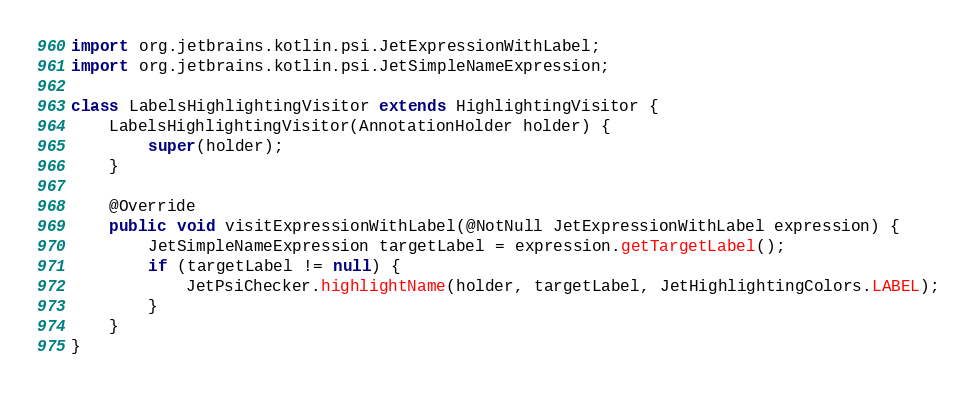Convert code to text. <code><loc_0><loc_0><loc_500><loc_500><_Java_>import org.jetbrains.kotlin.psi.JetExpressionWithLabel;
import org.jetbrains.kotlin.psi.JetSimpleNameExpression;

class LabelsHighlightingVisitor extends HighlightingVisitor {
    LabelsHighlightingVisitor(AnnotationHolder holder) {
        super(holder);
    }

    @Override
    public void visitExpressionWithLabel(@NotNull JetExpressionWithLabel expression) {
        JetSimpleNameExpression targetLabel = expression.getTargetLabel();
        if (targetLabel != null) {
            JetPsiChecker.highlightName(holder, targetLabel, JetHighlightingColors.LABEL);
        }
    }
}
</code> 